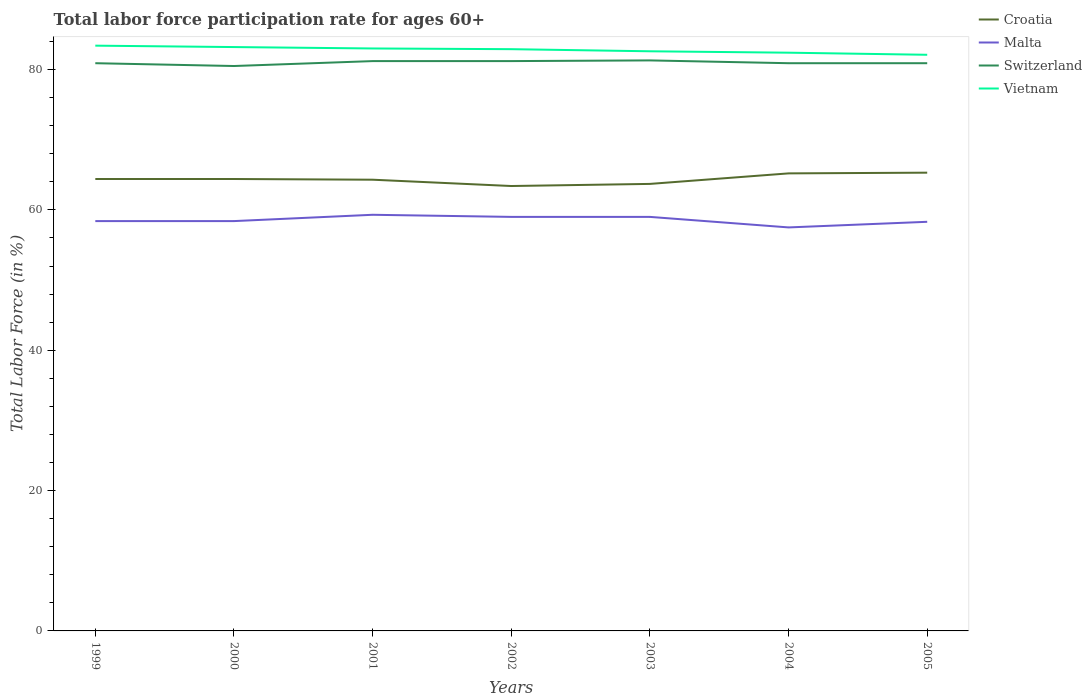Does the line corresponding to Croatia intersect with the line corresponding to Switzerland?
Keep it short and to the point. No. Across all years, what is the maximum labor force participation rate in Croatia?
Your answer should be compact. 63.4. In which year was the labor force participation rate in Vietnam maximum?
Provide a short and direct response. 2005. What is the total labor force participation rate in Switzerland in the graph?
Provide a short and direct response. -0.4. What is the difference between the highest and the second highest labor force participation rate in Switzerland?
Offer a terse response. 0.8. What is the difference between the highest and the lowest labor force participation rate in Switzerland?
Provide a short and direct response. 3. How many years are there in the graph?
Make the answer very short. 7. Are the values on the major ticks of Y-axis written in scientific E-notation?
Provide a short and direct response. No. Does the graph contain any zero values?
Keep it short and to the point. No. How are the legend labels stacked?
Your response must be concise. Vertical. What is the title of the graph?
Keep it short and to the point. Total labor force participation rate for ages 60+. What is the label or title of the X-axis?
Ensure brevity in your answer.  Years. What is the label or title of the Y-axis?
Give a very brief answer. Total Labor Force (in %). What is the Total Labor Force (in %) of Croatia in 1999?
Your answer should be very brief. 64.4. What is the Total Labor Force (in %) in Malta in 1999?
Provide a short and direct response. 58.4. What is the Total Labor Force (in %) in Switzerland in 1999?
Your response must be concise. 80.9. What is the Total Labor Force (in %) in Vietnam in 1999?
Ensure brevity in your answer.  83.4. What is the Total Labor Force (in %) in Croatia in 2000?
Provide a short and direct response. 64.4. What is the Total Labor Force (in %) of Malta in 2000?
Make the answer very short. 58.4. What is the Total Labor Force (in %) of Switzerland in 2000?
Provide a short and direct response. 80.5. What is the Total Labor Force (in %) of Vietnam in 2000?
Your answer should be very brief. 83.2. What is the Total Labor Force (in %) of Croatia in 2001?
Keep it short and to the point. 64.3. What is the Total Labor Force (in %) of Malta in 2001?
Your answer should be very brief. 59.3. What is the Total Labor Force (in %) of Switzerland in 2001?
Your response must be concise. 81.2. What is the Total Labor Force (in %) in Croatia in 2002?
Provide a short and direct response. 63.4. What is the Total Labor Force (in %) of Malta in 2002?
Offer a very short reply. 59. What is the Total Labor Force (in %) in Switzerland in 2002?
Make the answer very short. 81.2. What is the Total Labor Force (in %) of Vietnam in 2002?
Offer a terse response. 82.9. What is the Total Labor Force (in %) in Croatia in 2003?
Provide a short and direct response. 63.7. What is the Total Labor Force (in %) of Malta in 2003?
Give a very brief answer. 59. What is the Total Labor Force (in %) in Switzerland in 2003?
Make the answer very short. 81.3. What is the Total Labor Force (in %) in Vietnam in 2003?
Your answer should be compact. 82.6. What is the Total Labor Force (in %) of Croatia in 2004?
Provide a succinct answer. 65.2. What is the Total Labor Force (in %) in Malta in 2004?
Provide a succinct answer. 57.5. What is the Total Labor Force (in %) of Switzerland in 2004?
Make the answer very short. 80.9. What is the Total Labor Force (in %) in Vietnam in 2004?
Give a very brief answer. 82.4. What is the Total Labor Force (in %) in Croatia in 2005?
Offer a very short reply. 65.3. What is the Total Labor Force (in %) in Malta in 2005?
Offer a terse response. 58.3. What is the Total Labor Force (in %) of Switzerland in 2005?
Your response must be concise. 80.9. What is the Total Labor Force (in %) in Vietnam in 2005?
Ensure brevity in your answer.  82.1. Across all years, what is the maximum Total Labor Force (in %) in Croatia?
Ensure brevity in your answer.  65.3. Across all years, what is the maximum Total Labor Force (in %) of Malta?
Make the answer very short. 59.3. Across all years, what is the maximum Total Labor Force (in %) of Switzerland?
Offer a terse response. 81.3. Across all years, what is the maximum Total Labor Force (in %) of Vietnam?
Make the answer very short. 83.4. Across all years, what is the minimum Total Labor Force (in %) of Croatia?
Offer a very short reply. 63.4. Across all years, what is the minimum Total Labor Force (in %) in Malta?
Offer a very short reply. 57.5. Across all years, what is the minimum Total Labor Force (in %) in Switzerland?
Offer a very short reply. 80.5. Across all years, what is the minimum Total Labor Force (in %) of Vietnam?
Provide a short and direct response. 82.1. What is the total Total Labor Force (in %) of Croatia in the graph?
Make the answer very short. 450.7. What is the total Total Labor Force (in %) of Malta in the graph?
Your response must be concise. 409.9. What is the total Total Labor Force (in %) in Switzerland in the graph?
Make the answer very short. 566.9. What is the total Total Labor Force (in %) of Vietnam in the graph?
Ensure brevity in your answer.  579.6. What is the difference between the Total Labor Force (in %) of Vietnam in 1999 and that in 2000?
Make the answer very short. 0.2. What is the difference between the Total Labor Force (in %) of Croatia in 1999 and that in 2001?
Your answer should be very brief. 0.1. What is the difference between the Total Labor Force (in %) of Malta in 1999 and that in 2001?
Your answer should be compact. -0.9. What is the difference between the Total Labor Force (in %) of Switzerland in 1999 and that in 2001?
Give a very brief answer. -0.3. What is the difference between the Total Labor Force (in %) in Switzerland in 1999 and that in 2002?
Provide a succinct answer. -0.3. What is the difference between the Total Labor Force (in %) in Croatia in 1999 and that in 2004?
Your answer should be very brief. -0.8. What is the difference between the Total Labor Force (in %) of Malta in 1999 and that in 2004?
Make the answer very short. 0.9. What is the difference between the Total Labor Force (in %) in Vietnam in 1999 and that in 2004?
Offer a terse response. 1. What is the difference between the Total Labor Force (in %) in Croatia in 1999 and that in 2005?
Offer a very short reply. -0.9. What is the difference between the Total Labor Force (in %) of Malta in 1999 and that in 2005?
Give a very brief answer. 0.1. What is the difference between the Total Labor Force (in %) of Switzerland in 1999 and that in 2005?
Your answer should be compact. 0. What is the difference between the Total Labor Force (in %) of Malta in 2000 and that in 2001?
Give a very brief answer. -0.9. What is the difference between the Total Labor Force (in %) of Vietnam in 2000 and that in 2001?
Your answer should be compact. 0.2. What is the difference between the Total Labor Force (in %) of Malta in 2000 and that in 2002?
Provide a succinct answer. -0.6. What is the difference between the Total Labor Force (in %) of Switzerland in 2000 and that in 2002?
Ensure brevity in your answer.  -0.7. What is the difference between the Total Labor Force (in %) of Vietnam in 2000 and that in 2002?
Make the answer very short. 0.3. What is the difference between the Total Labor Force (in %) in Switzerland in 2000 and that in 2003?
Your answer should be compact. -0.8. What is the difference between the Total Labor Force (in %) of Vietnam in 2000 and that in 2003?
Your answer should be very brief. 0.6. What is the difference between the Total Labor Force (in %) in Croatia in 2000 and that in 2004?
Offer a very short reply. -0.8. What is the difference between the Total Labor Force (in %) of Malta in 2000 and that in 2004?
Your response must be concise. 0.9. What is the difference between the Total Labor Force (in %) of Croatia in 2000 and that in 2005?
Provide a short and direct response. -0.9. What is the difference between the Total Labor Force (in %) of Vietnam in 2000 and that in 2005?
Offer a terse response. 1.1. What is the difference between the Total Labor Force (in %) of Croatia in 2001 and that in 2002?
Offer a very short reply. 0.9. What is the difference between the Total Labor Force (in %) in Malta in 2001 and that in 2002?
Give a very brief answer. 0.3. What is the difference between the Total Labor Force (in %) of Switzerland in 2001 and that in 2002?
Ensure brevity in your answer.  0. What is the difference between the Total Labor Force (in %) of Vietnam in 2001 and that in 2002?
Give a very brief answer. 0.1. What is the difference between the Total Labor Force (in %) in Croatia in 2001 and that in 2003?
Offer a terse response. 0.6. What is the difference between the Total Labor Force (in %) in Malta in 2001 and that in 2003?
Make the answer very short. 0.3. What is the difference between the Total Labor Force (in %) in Vietnam in 2001 and that in 2003?
Your answer should be very brief. 0.4. What is the difference between the Total Labor Force (in %) of Malta in 2001 and that in 2004?
Provide a succinct answer. 1.8. What is the difference between the Total Labor Force (in %) of Vietnam in 2001 and that in 2004?
Give a very brief answer. 0.6. What is the difference between the Total Labor Force (in %) of Croatia in 2001 and that in 2005?
Give a very brief answer. -1. What is the difference between the Total Labor Force (in %) in Malta in 2001 and that in 2005?
Your answer should be compact. 1. What is the difference between the Total Labor Force (in %) of Switzerland in 2001 and that in 2005?
Offer a very short reply. 0.3. What is the difference between the Total Labor Force (in %) in Vietnam in 2001 and that in 2005?
Give a very brief answer. 0.9. What is the difference between the Total Labor Force (in %) in Croatia in 2002 and that in 2003?
Give a very brief answer. -0.3. What is the difference between the Total Labor Force (in %) in Malta in 2002 and that in 2003?
Your response must be concise. 0. What is the difference between the Total Labor Force (in %) in Vietnam in 2002 and that in 2003?
Provide a succinct answer. 0.3. What is the difference between the Total Labor Force (in %) of Malta in 2002 and that in 2004?
Your answer should be compact. 1.5. What is the difference between the Total Labor Force (in %) of Vietnam in 2002 and that in 2004?
Make the answer very short. 0.5. What is the difference between the Total Labor Force (in %) of Malta in 2002 and that in 2005?
Give a very brief answer. 0.7. What is the difference between the Total Labor Force (in %) of Vietnam in 2002 and that in 2005?
Your answer should be compact. 0.8. What is the difference between the Total Labor Force (in %) of Switzerland in 2003 and that in 2004?
Provide a short and direct response. 0.4. What is the difference between the Total Labor Force (in %) in Croatia in 2003 and that in 2005?
Offer a terse response. -1.6. What is the difference between the Total Labor Force (in %) in Vietnam in 2003 and that in 2005?
Keep it short and to the point. 0.5. What is the difference between the Total Labor Force (in %) in Switzerland in 2004 and that in 2005?
Offer a very short reply. 0. What is the difference between the Total Labor Force (in %) of Croatia in 1999 and the Total Labor Force (in %) of Switzerland in 2000?
Your response must be concise. -16.1. What is the difference between the Total Labor Force (in %) of Croatia in 1999 and the Total Labor Force (in %) of Vietnam in 2000?
Keep it short and to the point. -18.8. What is the difference between the Total Labor Force (in %) of Malta in 1999 and the Total Labor Force (in %) of Switzerland in 2000?
Your response must be concise. -22.1. What is the difference between the Total Labor Force (in %) in Malta in 1999 and the Total Labor Force (in %) in Vietnam in 2000?
Provide a succinct answer. -24.8. What is the difference between the Total Labor Force (in %) of Croatia in 1999 and the Total Labor Force (in %) of Switzerland in 2001?
Your response must be concise. -16.8. What is the difference between the Total Labor Force (in %) in Croatia in 1999 and the Total Labor Force (in %) in Vietnam in 2001?
Provide a short and direct response. -18.6. What is the difference between the Total Labor Force (in %) of Malta in 1999 and the Total Labor Force (in %) of Switzerland in 2001?
Your answer should be very brief. -22.8. What is the difference between the Total Labor Force (in %) in Malta in 1999 and the Total Labor Force (in %) in Vietnam in 2001?
Make the answer very short. -24.6. What is the difference between the Total Labor Force (in %) of Switzerland in 1999 and the Total Labor Force (in %) of Vietnam in 2001?
Your response must be concise. -2.1. What is the difference between the Total Labor Force (in %) in Croatia in 1999 and the Total Labor Force (in %) in Switzerland in 2002?
Your response must be concise. -16.8. What is the difference between the Total Labor Force (in %) in Croatia in 1999 and the Total Labor Force (in %) in Vietnam in 2002?
Provide a succinct answer. -18.5. What is the difference between the Total Labor Force (in %) of Malta in 1999 and the Total Labor Force (in %) of Switzerland in 2002?
Your answer should be compact. -22.8. What is the difference between the Total Labor Force (in %) of Malta in 1999 and the Total Labor Force (in %) of Vietnam in 2002?
Make the answer very short. -24.5. What is the difference between the Total Labor Force (in %) of Switzerland in 1999 and the Total Labor Force (in %) of Vietnam in 2002?
Your answer should be compact. -2. What is the difference between the Total Labor Force (in %) in Croatia in 1999 and the Total Labor Force (in %) in Malta in 2003?
Your response must be concise. 5.4. What is the difference between the Total Labor Force (in %) in Croatia in 1999 and the Total Labor Force (in %) in Switzerland in 2003?
Offer a terse response. -16.9. What is the difference between the Total Labor Force (in %) in Croatia in 1999 and the Total Labor Force (in %) in Vietnam in 2003?
Your answer should be very brief. -18.2. What is the difference between the Total Labor Force (in %) of Malta in 1999 and the Total Labor Force (in %) of Switzerland in 2003?
Offer a terse response. -22.9. What is the difference between the Total Labor Force (in %) of Malta in 1999 and the Total Labor Force (in %) of Vietnam in 2003?
Your response must be concise. -24.2. What is the difference between the Total Labor Force (in %) of Croatia in 1999 and the Total Labor Force (in %) of Switzerland in 2004?
Keep it short and to the point. -16.5. What is the difference between the Total Labor Force (in %) in Malta in 1999 and the Total Labor Force (in %) in Switzerland in 2004?
Your answer should be very brief. -22.5. What is the difference between the Total Labor Force (in %) of Malta in 1999 and the Total Labor Force (in %) of Vietnam in 2004?
Give a very brief answer. -24. What is the difference between the Total Labor Force (in %) in Croatia in 1999 and the Total Labor Force (in %) in Switzerland in 2005?
Make the answer very short. -16.5. What is the difference between the Total Labor Force (in %) of Croatia in 1999 and the Total Labor Force (in %) of Vietnam in 2005?
Your response must be concise. -17.7. What is the difference between the Total Labor Force (in %) of Malta in 1999 and the Total Labor Force (in %) of Switzerland in 2005?
Offer a very short reply. -22.5. What is the difference between the Total Labor Force (in %) of Malta in 1999 and the Total Labor Force (in %) of Vietnam in 2005?
Your answer should be very brief. -23.7. What is the difference between the Total Labor Force (in %) of Croatia in 2000 and the Total Labor Force (in %) of Switzerland in 2001?
Your response must be concise. -16.8. What is the difference between the Total Labor Force (in %) of Croatia in 2000 and the Total Labor Force (in %) of Vietnam in 2001?
Your answer should be compact. -18.6. What is the difference between the Total Labor Force (in %) in Malta in 2000 and the Total Labor Force (in %) in Switzerland in 2001?
Your response must be concise. -22.8. What is the difference between the Total Labor Force (in %) in Malta in 2000 and the Total Labor Force (in %) in Vietnam in 2001?
Offer a very short reply. -24.6. What is the difference between the Total Labor Force (in %) of Switzerland in 2000 and the Total Labor Force (in %) of Vietnam in 2001?
Give a very brief answer. -2.5. What is the difference between the Total Labor Force (in %) of Croatia in 2000 and the Total Labor Force (in %) of Malta in 2002?
Ensure brevity in your answer.  5.4. What is the difference between the Total Labor Force (in %) of Croatia in 2000 and the Total Labor Force (in %) of Switzerland in 2002?
Your answer should be compact. -16.8. What is the difference between the Total Labor Force (in %) in Croatia in 2000 and the Total Labor Force (in %) in Vietnam in 2002?
Keep it short and to the point. -18.5. What is the difference between the Total Labor Force (in %) in Malta in 2000 and the Total Labor Force (in %) in Switzerland in 2002?
Offer a very short reply. -22.8. What is the difference between the Total Labor Force (in %) in Malta in 2000 and the Total Labor Force (in %) in Vietnam in 2002?
Your answer should be compact. -24.5. What is the difference between the Total Labor Force (in %) of Switzerland in 2000 and the Total Labor Force (in %) of Vietnam in 2002?
Offer a very short reply. -2.4. What is the difference between the Total Labor Force (in %) of Croatia in 2000 and the Total Labor Force (in %) of Malta in 2003?
Your response must be concise. 5.4. What is the difference between the Total Labor Force (in %) in Croatia in 2000 and the Total Labor Force (in %) in Switzerland in 2003?
Ensure brevity in your answer.  -16.9. What is the difference between the Total Labor Force (in %) in Croatia in 2000 and the Total Labor Force (in %) in Vietnam in 2003?
Your answer should be very brief. -18.2. What is the difference between the Total Labor Force (in %) of Malta in 2000 and the Total Labor Force (in %) of Switzerland in 2003?
Your answer should be compact. -22.9. What is the difference between the Total Labor Force (in %) in Malta in 2000 and the Total Labor Force (in %) in Vietnam in 2003?
Your answer should be very brief. -24.2. What is the difference between the Total Labor Force (in %) of Croatia in 2000 and the Total Labor Force (in %) of Malta in 2004?
Provide a short and direct response. 6.9. What is the difference between the Total Labor Force (in %) in Croatia in 2000 and the Total Labor Force (in %) in Switzerland in 2004?
Offer a very short reply. -16.5. What is the difference between the Total Labor Force (in %) in Croatia in 2000 and the Total Labor Force (in %) in Vietnam in 2004?
Provide a succinct answer. -18. What is the difference between the Total Labor Force (in %) in Malta in 2000 and the Total Labor Force (in %) in Switzerland in 2004?
Ensure brevity in your answer.  -22.5. What is the difference between the Total Labor Force (in %) in Switzerland in 2000 and the Total Labor Force (in %) in Vietnam in 2004?
Provide a succinct answer. -1.9. What is the difference between the Total Labor Force (in %) of Croatia in 2000 and the Total Labor Force (in %) of Switzerland in 2005?
Provide a succinct answer. -16.5. What is the difference between the Total Labor Force (in %) of Croatia in 2000 and the Total Labor Force (in %) of Vietnam in 2005?
Make the answer very short. -17.7. What is the difference between the Total Labor Force (in %) of Malta in 2000 and the Total Labor Force (in %) of Switzerland in 2005?
Provide a succinct answer. -22.5. What is the difference between the Total Labor Force (in %) of Malta in 2000 and the Total Labor Force (in %) of Vietnam in 2005?
Ensure brevity in your answer.  -23.7. What is the difference between the Total Labor Force (in %) of Croatia in 2001 and the Total Labor Force (in %) of Switzerland in 2002?
Offer a terse response. -16.9. What is the difference between the Total Labor Force (in %) of Croatia in 2001 and the Total Labor Force (in %) of Vietnam in 2002?
Offer a terse response. -18.6. What is the difference between the Total Labor Force (in %) in Malta in 2001 and the Total Labor Force (in %) in Switzerland in 2002?
Offer a terse response. -21.9. What is the difference between the Total Labor Force (in %) of Malta in 2001 and the Total Labor Force (in %) of Vietnam in 2002?
Provide a succinct answer. -23.6. What is the difference between the Total Labor Force (in %) of Croatia in 2001 and the Total Labor Force (in %) of Malta in 2003?
Provide a short and direct response. 5.3. What is the difference between the Total Labor Force (in %) of Croatia in 2001 and the Total Labor Force (in %) of Vietnam in 2003?
Offer a very short reply. -18.3. What is the difference between the Total Labor Force (in %) in Malta in 2001 and the Total Labor Force (in %) in Switzerland in 2003?
Give a very brief answer. -22. What is the difference between the Total Labor Force (in %) of Malta in 2001 and the Total Labor Force (in %) of Vietnam in 2003?
Keep it short and to the point. -23.3. What is the difference between the Total Labor Force (in %) in Switzerland in 2001 and the Total Labor Force (in %) in Vietnam in 2003?
Give a very brief answer. -1.4. What is the difference between the Total Labor Force (in %) in Croatia in 2001 and the Total Labor Force (in %) in Switzerland in 2004?
Give a very brief answer. -16.6. What is the difference between the Total Labor Force (in %) of Croatia in 2001 and the Total Labor Force (in %) of Vietnam in 2004?
Keep it short and to the point. -18.1. What is the difference between the Total Labor Force (in %) in Malta in 2001 and the Total Labor Force (in %) in Switzerland in 2004?
Make the answer very short. -21.6. What is the difference between the Total Labor Force (in %) of Malta in 2001 and the Total Labor Force (in %) of Vietnam in 2004?
Give a very brief answer. -23.1. What is the difference between the Total Labor Force (in %) in Switzerland in 2001 and the Total Labor Force (in %) in Vietnam in 2004?
Offer a terse response. -1.2. What is the difference between the Total Labor Force (in %) in Croatia in 2001 and the Total Labor Force (in %) in Malta in 2005?
Provide a succinct answer. 6. What is the difference between the Total Labor Force (in %) of Croatia in 2001 and the Total Labor Force (in %) of Switzerland in 2005?
Offer a terse response. -16.6. What is the difference between the Total Labor Force (in %) in Croatia in 2001 and the Total Labor Force (in %) in Vietnam in 2005?
Offer a terse response. -17.8. What is the difference between the Total Labor Force (in %) in Malta in 2001 and the Total Labor Force (in %) in Switzerland in 2005?
Your response must be concise. -21.6. What is the difference between the Total Labor Force (in %) of Malta in 2001 and the Total Labor Force (in %) of Vietnam in 2005?
Your response must be concise. -22.8. What is the difference between the Total Labor Force (in %) of Croatia in 2002 and the Total Labor Force (in %) of Switzerland in 2003?
Your response must be concise. -17.9. What is the difference between the Total Labor Force (in %) of Croatia in 2002 and the Total Labor Force (in %) of Vietnam in 2003?
Your answer should be very brief. -19.2. What is the difference between the Total Labor Force (in %) in Malta in 2002 and the Total Labor Force (in %) in Switzerland in 2003?
Make the answer very short. -22.3. What is the difference between the Total Labor Force (in %) in Malta in 2002 and the Total Labor Force (in %) in Vietnam in 2003?
Offer a very short reply. -23.6. What is the difference between the Total Labor Force (in %) in Switzerland in 2002 and the Total Labor Force (in %) in Vietnam in 2003?
Provide a short and direct response. -1.4. What is the difference between the Total Labor Force (in %) in Croatia in 2002 and the Total Labor Force (in %) in Switzerland in 2004?
Your response must be concise. -17.5. What is the difference between the Total Labor Force (in %) of Croatia in 2002 and the Total Labor Force (in %) of Vietnam in 2004?
Your answer should be very brief. -19. What is the difference between the Total Labor Force (in %) in Malta in 2002 and the Total Labor Force (in %) in Switzerland in 2004?
Offer a very short reply. -21.9. What is the difference between the Total Labor Force (in %) of Malta in 2002 and the Total Labor Force (in %) of Vietnam in 2004?
Your answer should be compact. -23.4. What is the difference between the Total Labor Force (in %) of Croatia in 2002 and the Total Labor Force (in %) of Switzerland in 2005?
Offer a terse response. -17.5. What is the difference between the Total Labor Force (in %) of Croatia in 2002 and the Total Labor Force (in %) of Vietnam in 2005?
Keep it short and to the point. -18.7. What is the difference between the Total Labor Force (in %) of Malta in 2002 and the Total Labor Force (in %) of Switzerland in 2005?
Your answer should be very brief. -21.9. What is the difference between the Total Labor Force (in %) of Malta in 2002 and the Total Labor Force (in %) of Vietnam in 2005?
Provide a succinct answer. -23.1. What is the difference between the Total Labor Force (in %) in Switzerland in 2002 and the Total Labor Force (in %) in Vietnam in 2005?
Give a very brief answer. -0.9. What is the difference between the Total Labor Force (in %) of Croatia in 2003 and the Total Labor Force (in %) of Switzerland in 2004?
Ensure brevity in your answer.  -17.2. What is the difference between the Total Labor Force (in %) in Croatia in 2003 and the Total Labor Force (in %) in Vietnam in 2004?
Offer a terse response. -18.7. What is the difference between the Total Labor Force (in %) of Malta in 2003 and the Total Labor Force (in %) of Switzerland in 2004?
Offer a very short reply. -21.9. What is the difference between the Total Labor Force (in %) of Malta in 2003 and the Total Labor Force (in %) of Vietnam in 2004?
Give a very brief answer. -23.4. What is the difference between the Total Labor Force (in %) of Switzerland in 2003 and the Total Labor Force (in %) of Vietnam in 2004?
Your answer should be compact. -1.1. What is the difference between the Total Labor Force (in %) of Croatia in 2003 and the Total Labor Force (in %) of Malta in 2005?
Provide a succinct answer. 5.4. What is the difference between the Total Labor Force (in %) in Croatia in 2003 and the Total Labor Force (in %) in Switzerland in 2005?
Offer a very short reply. -17.2. What is the difference between the Total Labor Force (in %) of Croatia in 2003 and the Total Labor Force (in %) of Vietnam in 2005?
Give a very brief answer. -18.4. What is the difference between the Total Labor Force (in %) in Malta in 2003 and the Total Labor Force (in %) in Switzerland in 2005?
Provide a short and direct response. -21.9. What is the difference between the Total Labor Force (in %) of Malta in 2003 and the Total Labor Force (in %) of Vietnam in 2005?
Provide a short and direct response. -23.1. What is the difference between the Total Labor Force (in %) in Croatia in 2004 and the Total Labor Force (in %) in Switzerland in 2005?
Keep it short and to the point. -15.7. What is the difference between the Total Labor Force (in %) in Croatia in 2004 and the Total Labor Force (in %) in Vietnam in 2005?
Give a very brief answer. -16.9. What is the difference between the Total Labor Force (in %) of Malta in 2004 and the Total Labor Force (in %) of Switzerland in 2005?
Offer a very short reply. -23.4. What is the difference between the Total Labor Force (in %) of Malta in 2004 and the Total Labor Force (in %) of Vietnam in 2005?
Make the answer very short. -24.6. What is the average Total Labor Force (in %) of Croatia per year?
Your answer should be compact. 64.39. What is the average Total Labor Force (in %) of Malta per year?
Provide a succinct answer. 58.56. What is the average Total Labor Force (in %) in Switzerland per year?
Make the answer very short. 80.99. What is the average Total Labor Force (in %) in Vietnam per year?
Your answer should be very brief. 82.8. In the year 1999, what is the difference between the Total Labor Force (in %) of Croatia and Total Labor Force (in %) of Malta?
Your response must be concise. 6. In the year 1999, what is the difference between the Total Labor Force (in %) in Croatia and Total Labor Force (in %) in Switzerland?
Ensure brevity in your answer.  -16.5. In the year 1999, what is the difference between the Total Labor Force (in %) of Malta and Total Labor Force (in %) of Switzerland?
Keep it short and to the point. -22.5. In the year 1999, what is the difference between the Total Labor Force (in %) of Malta and Total Labor Force (in %) of Vietnam?
Your response must be concise. -25. In the year 2000, what is the difference between the Total Labor Force (in %) in Croatia and Total Labor Force (in %) in Malta?
Provide a short and direct response. 6. In the year 2000, what is the difference between the Total Labor Force (in %) of Croatia and Total Labor Force (in %) of Switzerland?
Offer a terse response. -16.1. In the year 2000, what is the difference between the Total Labor Force (in %) of Croatia and Total Labor Force (in %) of Vietnam?
Your response must be concise. -18.8. In the year 2000, what is the difference between the Total Labor Force (in %) of Malta and Total Labor Force (in %) of Switzerland?
Offer a terse response. -22.1. In the year 2000, what is the difference between the Total Labor Force (in %) in Malta and Total Labor Force (in %) in Vietnam?
Offer a terse response. -24.8. In the year 2001, what is the difference between the Total Labor Force (in %) in Croatia and Total Labor Force (in %) in Malta?
Offer a very short reply. 5. In the year 2001, what is the difference between the Total Labor Force (in %) of Croatia and Total Labor Force (in %) of Switzerland?
Provide a succinct answer. -16.9. In the year 2001, what is the difference between the Total Labor Force (in %) in Croatia and Total Labor Force (in %) in Vietnam?
Your answer should be very brief. -18.7. In the year 2001, what is the difference between the Total Labor Force (in %) of Malta and Total Labor Force (in %) of Switzerland?
Provide a short and direct response. -21.9. In the year 2001, what is the difference between the Total Labor Force (in %) in Malta and Total Labor Force (in %) in Vietnam?
Your answer should be compact. -23.7. In the year 2001, what is the difference between the Total Labor Force (in %) of Switzerland and Total Labor Force (in %) of Vietnam?
Ensure brevity in your answer.  -1.8. In the year 2002, what is the difference between the Total Labor Force (in %) in Croatia and Total Labor Force (in %) in Switzerland?
Offer a very short reply. -17.8. In the year 2002, what is the difference between the Total Labor Force (in %) in Croatia and Total Labor Force (in %) in Vietnam?
Provide a succinct answer. -19.5. In the year 2002, what is the difference between the Total Labor Force (in %) of Malta and Total Labor Force (in %) of Switzerland?
Ensure brevity in your answer.  -22.2. In the year 2002, what is the difference between the Total Labor Force (in %) of Malta and Total Labor Force (in %) of Vietnam?
Keep it short and to the point. -23.9. In the year 2003, what is the difference between the Total Labor Force (in %) in Croatia and Total Labor Force (in %) in Malta?
Provide a succinct answer. 4.7. In the year 2003, what is the difference between the Total Labor Force (in %) of Croatia and Total Labor Force (in %) of Switzerland?
Keep it short and to the point. -17.6. In the year 2003, what is the difference between the Total Labor Force (in %) of Croatia and Total Labor Force (in %) of Vietnam?
Your response must be concise. -18.9. In the year 2003, what is the difference between the Total Labor Force (in %) of Malta and Total Labor Force (in %) of Switzerland?
Make the answer very short. -22.3. In the year 2003, what is the difference between the Total Labor Force (in %) of Malta and Total Labor Force (in %) of Vietnam?
Your response must be concise. -23.6. In the year 2003, what is the difference between the Total Labor Force (in %) in Switzerland and Total Labor Force (in %) in Vietnam?
Offer a terse response. -1.3. In the year 2004, what is the difference between the Total Labor Force (in %) in Croatia and Total Labor Force (in %) in Switzerland?
Offer a terse response. -15.7. In the year 2004, what is the difference between the Total Labor Force (in %) of Croatia and Total Labor Force (in %) of Vietnam?
Offer a very short reply. -17.2. In the year 2004, what is the difference between the Total Labor Force (in %) in Malta and Total Labor Force (in %) in Switzerland?
Your answer should be compact. -23.4. In the year 2004, what is the difference between the Total Labor Force (in %) in Malta and Total Labor Force (in %) in Vietnam?
Provide a succinct answer. -24.9. In the year 2004, what is the difference between the Total Labor Force (in %) in Switzerland and Total Labor Force (in %) in Vietnam?
Give a very brief answer. -1.5. In the year 2005, what is the difference between the Total Labor Force (in %) of Croatia and Total Labor Force (in %) of Malta?
Keep it short and to the point. 7. In the year 2005, what is the difference between the Total Labor Force (in %) in Croatia and Total Labor Force (in %) in Switzerland?
Provide a short and direct response. -15.6. In the year 2005, what is the difference between the Total Labor Force (in %) in Croatia and Total Labor Force (in %) in Vietnam?
Provide a succinct answer. -16.8. In the year 2005, what is the difference between the Total Labor Force (in %) of Malta and Total Labor Force (in %) of Switzerland?
Provide a short and direct response. -22.6. In the year 2005, what is the difference between the Total Labor Force (in %) of Malta and Total Labor Force (in %) of Vietnam?
Give a very brief answer. -23.8. What is the ratio of the Total Labor Force (in %) of Croatia in 1999 to that in 2000?
Ensure brevity in your answer.  1. What is the ratio of the Total Labor Force (in %) of Malta in 1999 to that in 2000?
Make the answer very short. 1. What is the ratio of the Total Labor Force (in %) of Malta in 1999 to that in 2001?
Make the answer very short. 0.98. What is the ratio of the Total Labor Force (in %) in Switzerland in 1999 to that in 2001?
Make the answer very short. 1. What is the ratio of the Total Labor Force (in %) in Croatia in 1999 to that in 2002?
Offer a terse response. 1.02. What is the ratio of the Total Labor Force (in %) in Malta in 1999 to that in 2002?
Your response must be concise. 0.99. What is the ratio of the Total Labor Force (in %) of Vietnam in 1999 to that in 2002?
Your response must be concise. 1.01. What is the ratio of the Total Labor Force (in %) in Malta in 1999 to that in 2003?
Your response must be concise. 0.99. What is the ratio of the Total Labor Force (in %) of Vietnam in 1999 to that in 2003?
Your response must be concise. 1.01. What is the ratio of the Total Labor Force (in %) of Croatia in 1999 to that in 2004?
Your answer should be compact. 0.99. What is the ratio of the Total Labor Force (in %) in Malta in 1999 to that in 2004?
Keep it short and to the point. 1.02. What is the ratio of the Total Labor Force (in %) of Switzerland in 1999 to that in 2004?
Make the answer very short. 1. What is the ratio of the Total Labor Force (in %) in Vietnam in 1999 to that in 2004?
Offer a very short reply. 1.01. What is the ratio of the Total Labor Force (in %) in Croatia in 1999 to that in 2005?
Provide a short and direct response. 0.99. What is the ratio of the Total Labor Force (in %) of Malta in 1999 to that in 2005?
Your response must be concise. 1. What is the ratio of the Total Labor Force (in %) of Vietnam in 1999 to that in 2005?
Your answer should be compact. 1.02. What is the ratio of the Total Labor Force (in %) of Malta in 2000 to that in 2001?
Your response must be concise. 0.98. What is the ratio of the Total Labor Force (in %) of Switzerland in 2000 to that in 2001?
Your answer should be very brief. 0.99. What is the ratio of the Total Labor Force (in %) in Vietnam in 2000 to that in 2001?
Provide a succinct answer. 1. What is the ratio of the Total Labor Force (in %) of Croatia in 2000 to that in 2002?
Make the answer very short. 1.02. What is the ratio of the Total Labor Force (in %) of Switzerland in 2000 to that in 2002?
Keep it short and to the point. 0.99. What is the ratio of the Total Labor Force (in %) of Switzerland in 2000 to that in 2003?
Keep it short and to the point. 0.99. What is the ratio of the Total Labor Force (in %) of Vietnam in 2000 to that in 2003?
Your answer should be compact. 1.01. What is the ratio of the Total Labor Force (in %) in Croatia in 2000 to that in 2004?
Your response must be concise. 0.99. What is the ratio of the Total Labor Force (in %) in Malta in 2000 to that in 2004?
Your answer should be compact. 1.02. What is the ratio of the Total Labor Force (in %) in Switzerland in 2000 to that in 2004?
Give a very brief answer. 1. What is the ratio of the Total Labor Force (in %) in Vietnam in 2000 to that in 2004?
Ensure brevity in your answer.  1.01. What is the ratio of the Total Labor Force (in %) of Croatia in 2000 to that in 2005?
Make the answer very short. 0.99. What is the ratio of the Total Labor Force (in %) of Malta in 2000 to that in 2005?
Provide a succinct answer. 1. What is the ratio of the Total Labor Force (in %) of Vietnam in 2000 to that in 2005?
Provide a short and direct response. 1.01. What is the ratio of the Total Labor Force (in %) in Croatia in 2001 to that in 2002?
Your answer should be very brief. 1.01. What is the ratio of the Total Labor Force (in %) in Switzerland in 2001 to that in 2002?
Provide a short and direct response. 1. What is the ratio of the Total Labor Force (in %) in Vietnam in 2001 to that in 2002?
Your response must be concise. 1. What is the ratio of the Total Labor Force (in %) in Croatia in 2001 to that in 2003?
Ensure brevity in your answer.  1.01. What is the ratio of the Total Labor Force (in %) in Malta in 2001 to that in 2003?
Offer a very short reply. 1.01. What is the ratio of the Total Labor Force (in %) in Switzerland in 2001 to that in 2003?
Offer a very short reply. 1. What is the ratio of the Total Labor Force (in %) in Vietnam in 2001 to that in 2003?
Your answer should be very brief. 1. What is the ratio of the Total Labor Force (in %) of Croatia in 2001 to that in 2004?
Provide a succinct answer. 0.99. What is the ratio of the Total Labor Force (in %) in Malta in 2001 to that in 2004?
Your answer should be compact. 1.03. What is the ratio of the Total Labor Force (in %) in Vietnam in 2001 to that in 2004?
Make the answer very short. 1.01. What is the ratio of the Total Labor Force (in %) in Croatia in 2001 to that in 2005?
Keep it short and to the point. 0.98. What is the ratio of the Total Labor Force (in %) in Malta in 2001 to that in 2005?
Your answer should be very brief. 1.02. What is the ratio of the Total Labor Force (in %) of Vietnam in 2001 to that in 2005?
Offer a very short reply. 1.01. What is the ratio of the Total Labor Force (in %) in Malta in 2002 to that in 2003?
Provide a short and direct response. 1. What is the ratio of the Total Labor Force (in %) in Croatia in 2002 to that in 2004?
Your answer should be compact. 0.97. What is the ratio of the Total Labor Force (in %) in Malta in 2002 to that in 2004?
Provide a short and direct response. 1.03. What is the ratio of the Total Labor Force (in %) in Vietnam in 2002 to that in 2004?
Ensure brevity in your answer.  1.01. What is the ratio of the Total Labor Force (in %) in Croatia in 2002 to that in 2005?
Keep it short and to the point. 0.97. What is the ratio of the Total Labor Force (in %) of Switzerland in 2002 to that in 2005?
Your answer should be very brief. 1. What is the ratio of the Total Labor Force (in %) in Vietnam in 2002 to that in 2005?
Make the answer very short. 1.01. What is the ratio of the Total Labor Force (in %) of Malta in 2003 to that in 2004?
Your answer should be compact. 1.03. What is the ratio of the Total Labor Force (in %) of Switzerland in 2003 to that in 2004?
Keep it short and to the point. 1. What is the ratio of the Total Labor Force (in %) in Croatia in 2003 to that in 2005?
Give a very brief answer. 0.98. What is the ratio of the Total Labor Force (in %) of Malta in 2003 to that in 2005?
Ensure brevity in your answer.  1.01. What is the ratio of the Total Labor Force (in %) of Switzerland in 2003 to that in 2005?
Give a very brief answer. 1. What is the ratio of the Total Labor Force (in %) in Malta in 2004 to that in 2005?
Give a very brief answer. 0.99. What is the ratio of the Total Labor Force (in %) of Vietnam in 2004 to that in 2005?
Make the answer very short. 1. What is the difference between the highest and the second highest Total Labor Force (in %) in Croatia?
Provide a short and direct response. 0.1. What is the difference between the highest and the second highest Total Labor Force (in %) of Switzerland?
Your answer should be compact. 0.1. 